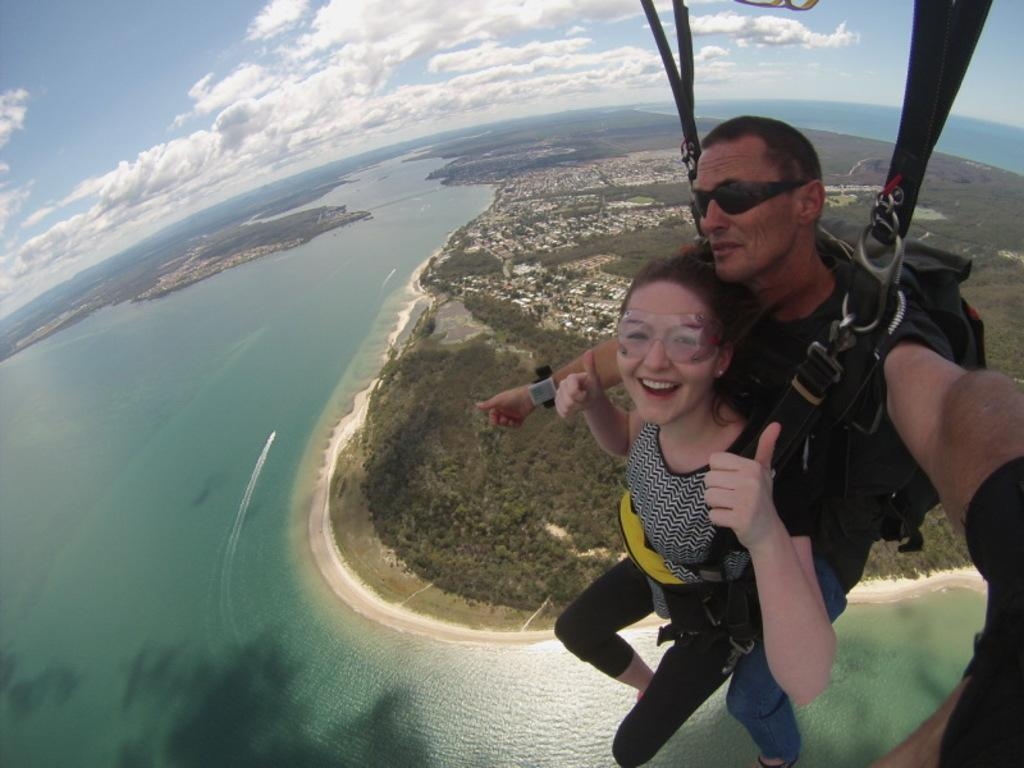How many people are in the image? There are two persons in the image. What do the two persons have in common? The two persons are wearing the same belts. Where are the two persons located in the image? The two persons are in the air. What is visible at the bottom of the image? There is an ocean at the bottom of the image. What type of vegetation can be seen in the image? There are trees in the image. What type of man-made structures are present in the image? There are buildings in the image. What is visible at the top of the image? The sky is visible at the top of the image. What type of wood is used to make the decision in the image? There is no wood or decision-making process depicted in the image. 